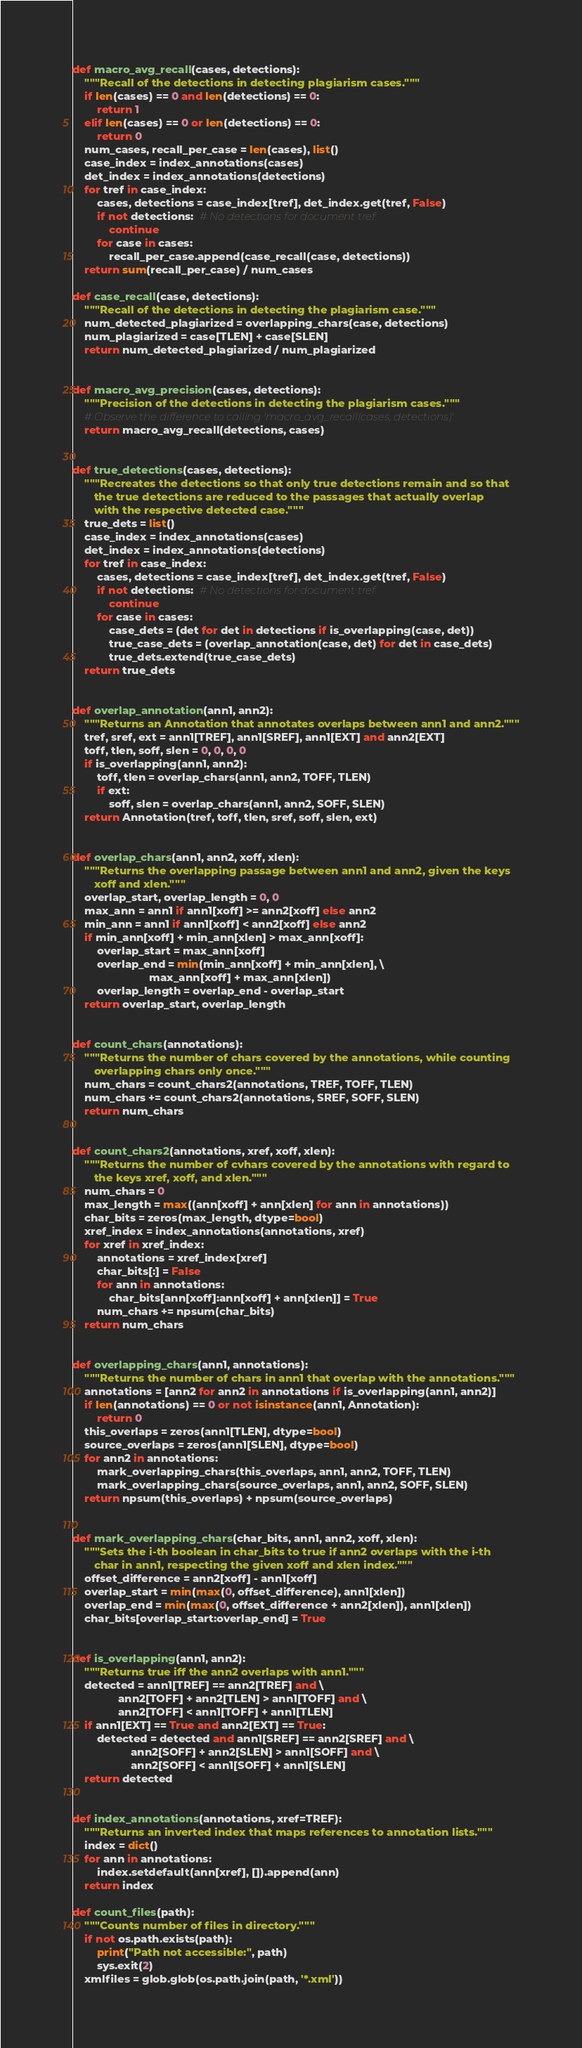Convert code to text. <code><loc_0><loc_0><loc_500><loc_500><_Python_>def macro_avg_recall(cases, detections):
    """Recall of the detections in detecting plagiarism cases."""
    if len(cases) == 0 and len(detections) == 0:
        return 1
    elif len(cases) == 0 or len(detections) == 0:
        return 0
    num_cases, recall_per_case = len(cases), list()
    case_index = index_annotations(cases)
    det_index = index_annotations(detections)
    for tref in case_index:
        cases, detections = case_index[tref], det_index.get(tref, False)
        if not detections:  # No detections for document tref.
            continue
        for case in cases:
            recall_per_case.append(case_recall(case, detections))
    return sum(recall_per_case) / num_cases

def case_recall(case, detections):
    """Recall of the detections in detecting the plagiarism case."""
    num_detected_plagiarized = overlapping_chars(case, detections)
    num_plagiarized = case[TLEN] + case[SLEN]
    return num_detected_plagiarized / num_plagiarized


def macro_avg_precision(cases, detections):
    """Precision of the detections in detecting the plagiarism cases."""
    # Observe the difference to calling 'macro_avg_recall(cases, detections)'.
    return macro_avg_recall(detections, cases)


def true_detections(cases, detections):
    """Recreates the detections so that only true detections remain and so that
       the true detections are reduced to the passages that actually overlap
       with the respective detected case."""
    true_dets = list()
    case_index = index_annotations(cases)
    det_index = index_annotations(detections)
    for tref in case_index:
        cases, detections = case_index[tref], det_index.get(tref, False)
        if not detections:  # No detections for document tref.
            continue
        for case in cases:
            case_dets = (det for det in detections if is_overlapping(case, det))
            true_case_dets = (overlap_annotation(case, det) for det in case_dets)
            true_dets.extend(true_case_dets)
    return true_dets


def overlap_annotation(ann1, ann2):
    """Returns an Annotation that annotates overlaps between ann1 and ann2."""
    tref, sref, ext = ann1[TREF], ann1[SREF], ann1[EXT] and ann2[EXT]
    toff, tlen, soff, slen = 0, 0, 0, 0
    if is_overlapping(ann1, ann2):
        toff, tlen = overlap_chars(ann1, ann2, TOFF, TLEN)
        if ext:
            soff, slen = overlap_chars(ann1, ann2, SOFF, SLEN)
    return Annotation(tref, toff, tlen, sref, soff, slen, ext)


def overlap_chars(ann1, ann2, xoff, xlen):
    """Returns the overlapping passage between ann1 and ann2, given the keys
       xoff and xlen."""
    overlap_start, overlap_length = 0, 0
    max_ann = ann1 if ann1[xoff] >= ann2[xoff] else ann2
    min_ann = ann1 if ann1[xoff] < ann2[xoff] else ann2
    if min_ann[xoff] + min_ann[xlen] > max_ann[xoff]:
        overlap_start = max_ann[xoff]
        overlap_end = min(min_ann[xoff] + min_ann[xlen], \
                         max_ann[xoff] + max_ann[xlen])
        overlap_length = overlap_end - overlap_start
    return overlap_start, overlap_length


def count_chars(annotations):
    """Returns the number of chars covered by the annotations, while counting
       overlapping chars only once."""
    num_chars = count_chars2(annotations, TREF, TOFF, TLEN)
    num_chars += count_chars2(annotations, SREF, SOFF, SLEN)
    return num_chars


def count_chars2(annotations, xref, xoff, xlen):
    """Returns the number of cvhars covered by the annotations with regard to
       the keys xref, xoff, and xlen."""
    num_chars = 0
    max_length = max((ann[xoff] + ann[xlen] for ann in annotations))
    char_bits = zeros(max_length, dtype=bool)
    xref_index = index_annotations(annotations, xref)
    for xref in xref_index:
        annotations = xref_index[xref]
        char_bits[:] = False
        for ann in annotations:
            char_bits[ann[xoff]:ann[xoff] + ann[xlen]] = True
        num_chars += npsum(char_bits)
    return num_chars


def overlapping_chars(ann1, annotations):
    """Returns the number of chars in ann1 that overlap with the annotations."""
    annotations = [ann2 for ann2 in annotations if is_overlapping(ann1, ann2)]
    if len(annotations) == 0 or not isinstance(ann1, Annotation):
        return 0
    this_overlaps = zeros(ann1[TLEN], dtype=bool)
    source_overlaps = zeros(ann1[SLEN], dtype=bool)
    for ann2 in annotations:
        mark_overlapping_chars(this_overlaps, ann1, ann2, TOFF, TLEN)
        mark_overlapping_chars(source_overlaps, ann1, ann2, SOFF, SLEN)
    return npsum(this_overlaps) + npsum(source_overlaps)


def mark_overlapping_chars(char_bits, ann1, ann2, xoff, xlen):
    """Sets the i-th boolean in char_bits to true if ann2 overlaps with the i-th
       char in ann1, respecting the given xoff and xlen index."""
    offset_difference = ann2[xoff] - ann1[xoff]
    overlap_start = min(max(0, offset_difference), ann1[xlen])
    overlap_end = min(max(0, offset_difference + ann2[xlen]), ann1[xlen])
    char_bits[overlap_start:overlap_end] = True


def is_overlapping(ann1, ann2):
    """Returns true iff the ann2 overlaps with ann1."""
    detected = ann1[TREF] == ann2[TREF] and \
               ann2[TOFF] + ann2[TLEN] > ann1[TOFF] and \
               ann2[TOFF] < ann1[TOFF] + ann1[TLEN]
    if ann1[EXT] == True and ann2[EXT] == True:
        detected = detected and ann1[SREF] == ann2[SREF] and \
                   ann2[SOFF] + ann2[SLEN] > ann1[SOFF] and \
                   ann2[SOFF] < ann1[SOFF] + ann1[SLEN]
    return detected


def index_annotations(annotations, xref=TREF):
    """Returns an inverted index that maps references to annotation lists."""
    index = dict()
    for ann in annotations:
        index.setdefault(ann[xref], []).append(ann)
    return index

def count_files(path):
    """Counts number of files in directory."""
    if not os.path.exists(path):
        print("Path not accessible:", path)
        sys.exit(2)
    xmlfiles = glob.glob(os.path.join(path, '*.xml'))</code> 